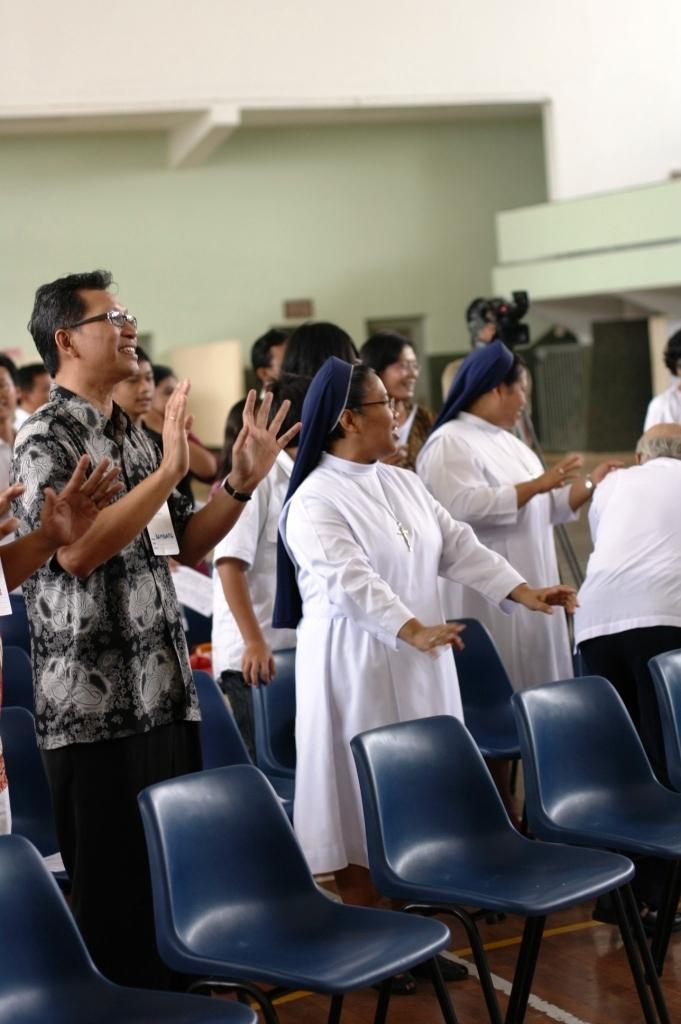What are the people in the image wearing? The persons in the image are wearing clothes. How are the persons positioned in relation to each other? The persons are standing in front of each other. What is located behind the persons in the image? There is a wall behind the persons. Can you describe any accessories worn by the persons? One person is wearing spectacles on their head. What type of brass instrument is being played by the person in the image? There is no brass instrument present in the image. What knowledge can be gained from the image? The image does not convey any specific knowledge or information beyond the details mentioned in the conversation. 